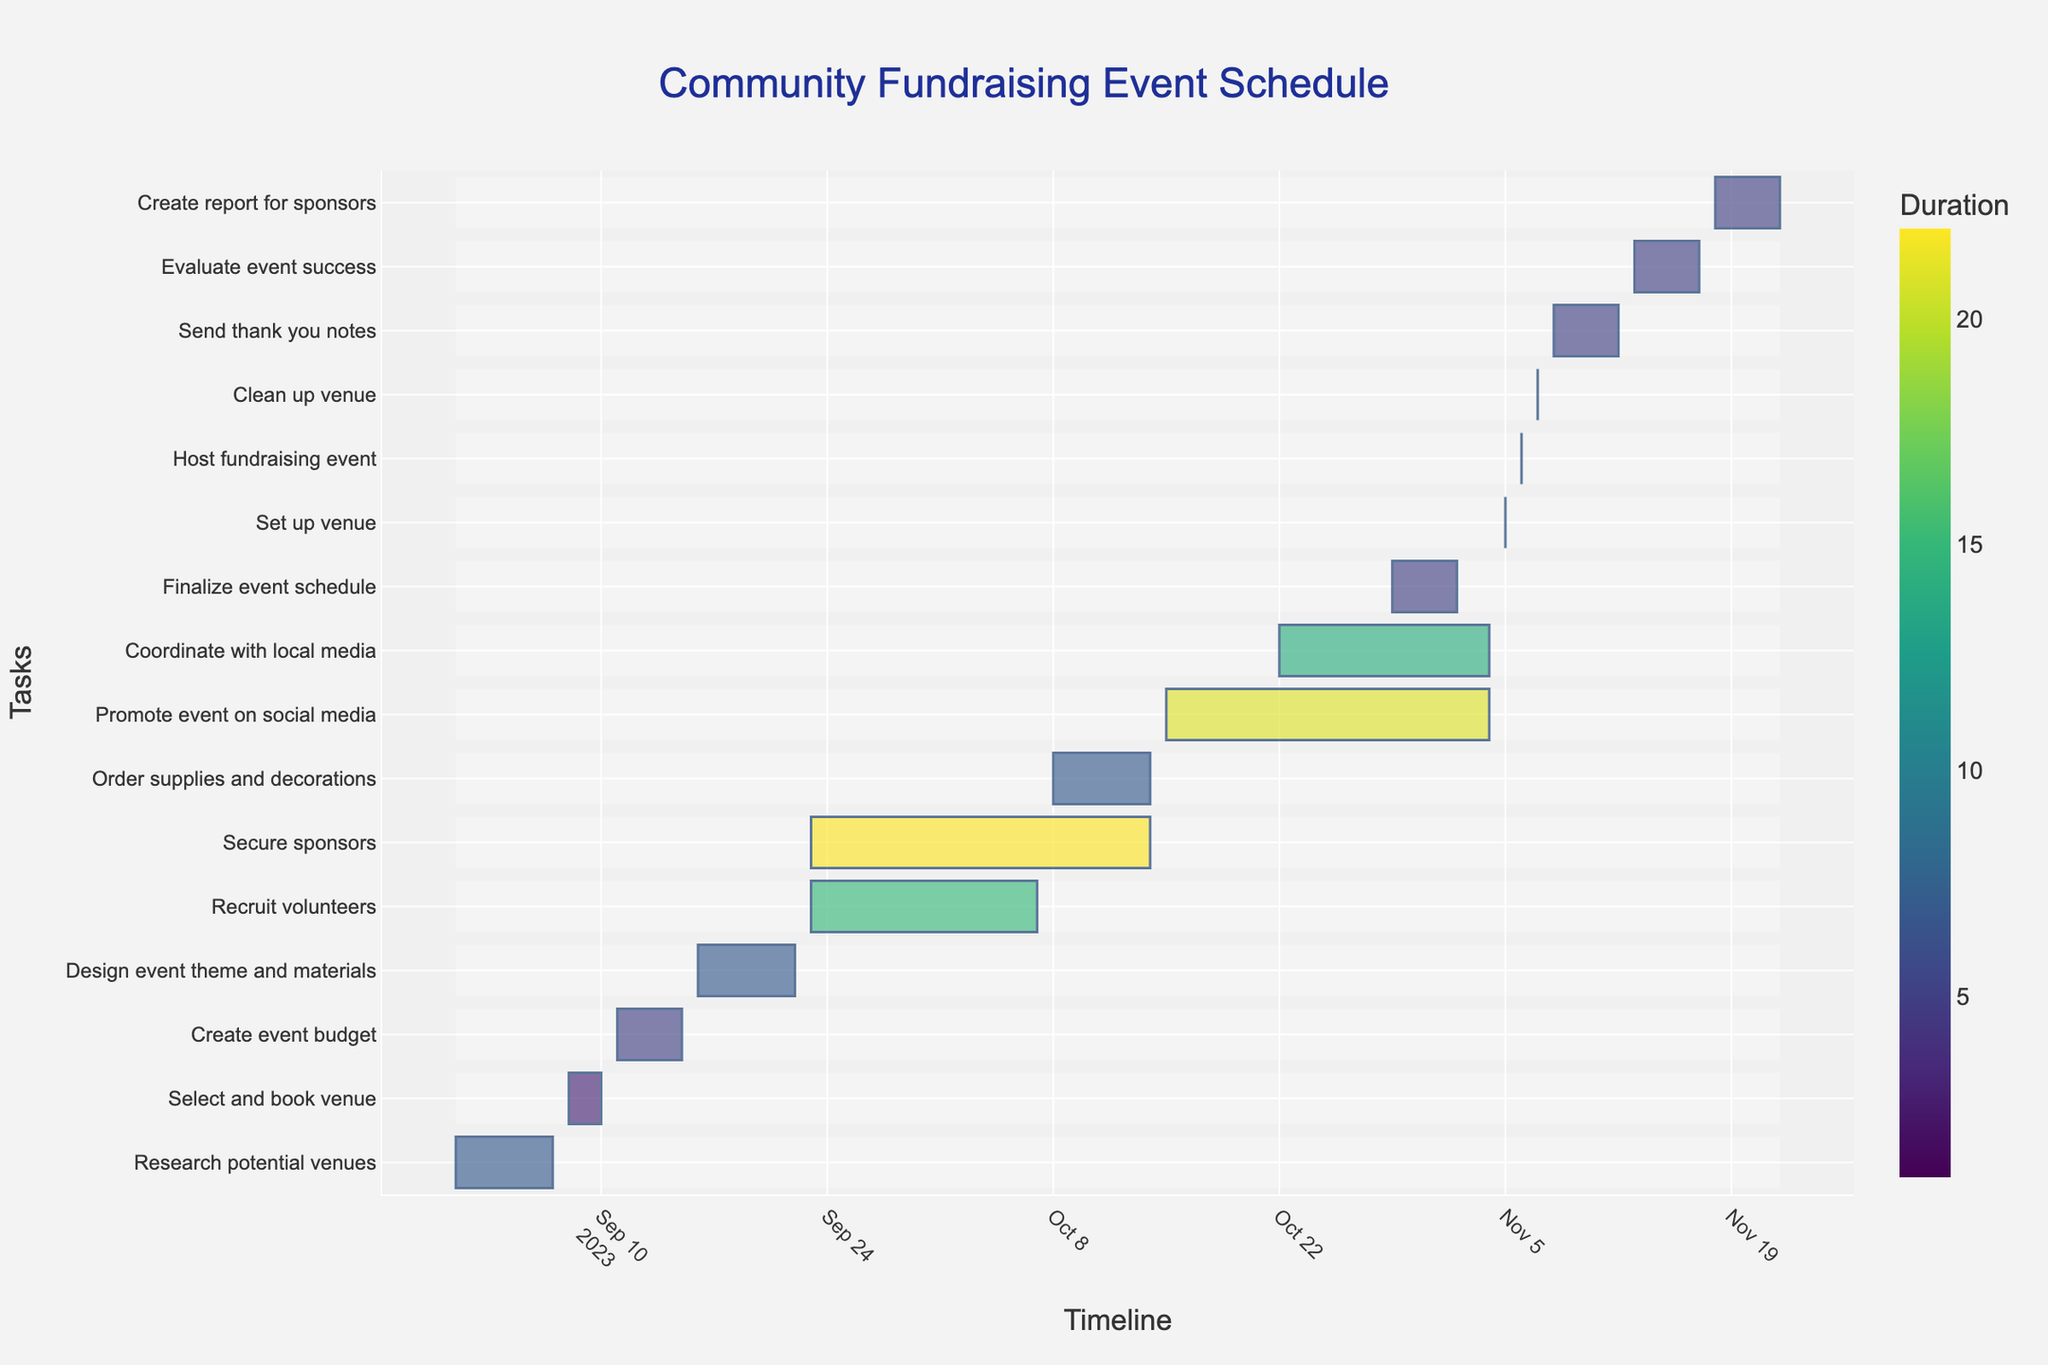What's the title of the figure? The title is located at the top center of the figure.
Answer: Community Fundraising Event Schedule When does the event budget creation task start and end? Look for the "Create event budget" task on the y-axis and check the corresponding dates on the x-axis.
Answer: September 11 to September 15 Which task has the longest duration? Check the colored bars and their lengths. The one that spans the most days on the x-axis is the task with the longest duration.
Answer: Recruit volunteers How many days is the "Promote event on social media" task scheduled to last? Find the "Promote event on social media" task and subtract its start date from its end date, then add 1 (to include the end date itself).
Answer: 21 days Which task overlaps with the "Order supplies and decorations" task? Identify the time span for "Order supplies and decorations" and see which other tasks have bars intersecting this time period.
Answer: Secure sponsors Which task occurs last in the timeline? Look at the very end of the x-axis and find the final task listed on the y-axis with a bar extending to the latest date.
Answer: Create report for sponsors Between which dates is the task "Finalize event schedule" scheduled? Locate "Finalize event schedule" in the list of tasks and check its start and end dates on the x-axis.
Answer: October 29 to November 2 How does the duration of "Send thank you notes" compare to "Evaluate event success"? Check the lengths (in days) of the bars for both tasks. Compare them by subtracting the start dates from the end dates for each task.
Answer: Send thank you notes is shorter Which tasks are concurrently scheduled on October 9? Identify all tasks that span across October 9 by checking their durations.
Answer: Recruit volunteers, Secure sponsors, Order supplies and decorations How many days are there between the "Set up venue" and "Clean up venue" tasks? Find the dates for "Set up venue" and "Clean up venue" tasks and calculate the difference between them (subtract the date of "Set up venue" from "Clean up venue").
Answer: 1 day 